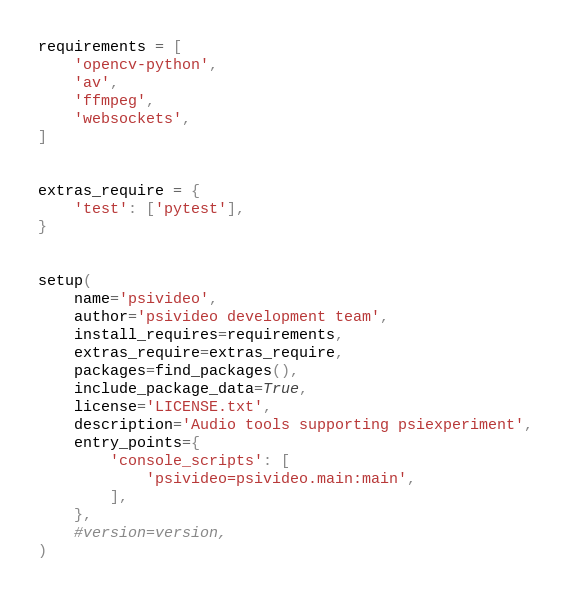Convert code to text. <code><loc_0><loc_0><loc_500><loc_500><_Python_>

requirements = [
    'opencv-python',
    'av',
    'ffmpeg',
    'websockets',
]


extras_require = {
    'test': ['pytest'],
}


setup(
    name='psivideo',
    author='psivideo development team',
    install_requires=requirements,
    extras_require=extras_require,
    packages=find_packages(),
    include_package_data=True,
    license='LICENSE.txt',
    description='Audio tools supporting psiexperiment',
    entry_points={
        'console_scripts': [
            'psivideo=psivideo.main:main',
        ],
    },
    #version=version,
)
</code> 